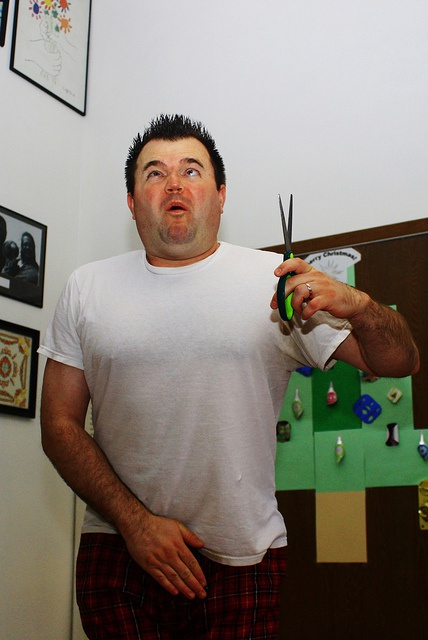Describe the objects in this image and their specific colors. I can see people in black, darkgray, maroon, and lightgray tones and scissors in black, gray, green, and maroon tones in this image. 